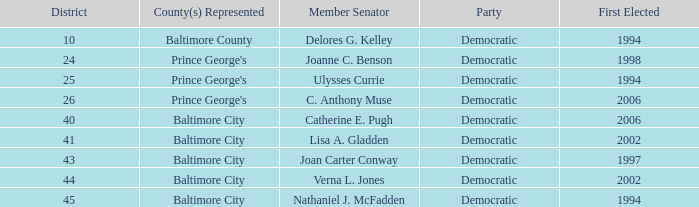Who was first chosen in 2002 in a district bigger than 41? Verna L. Jones. 